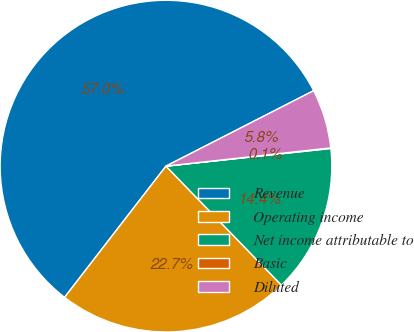<chart> <loc_0><loc_0><loc_500><loc_500><pie_chart><fcel>Revenue<fcel>Operating income<fcel>Net income attributable to<fcel>Basic<fcel>Diluted<nl><fcel>57.01%<fcel>22.73%<fcel>14.44%<fcel>0.06%<fcel>5.76%<nl></chart> 